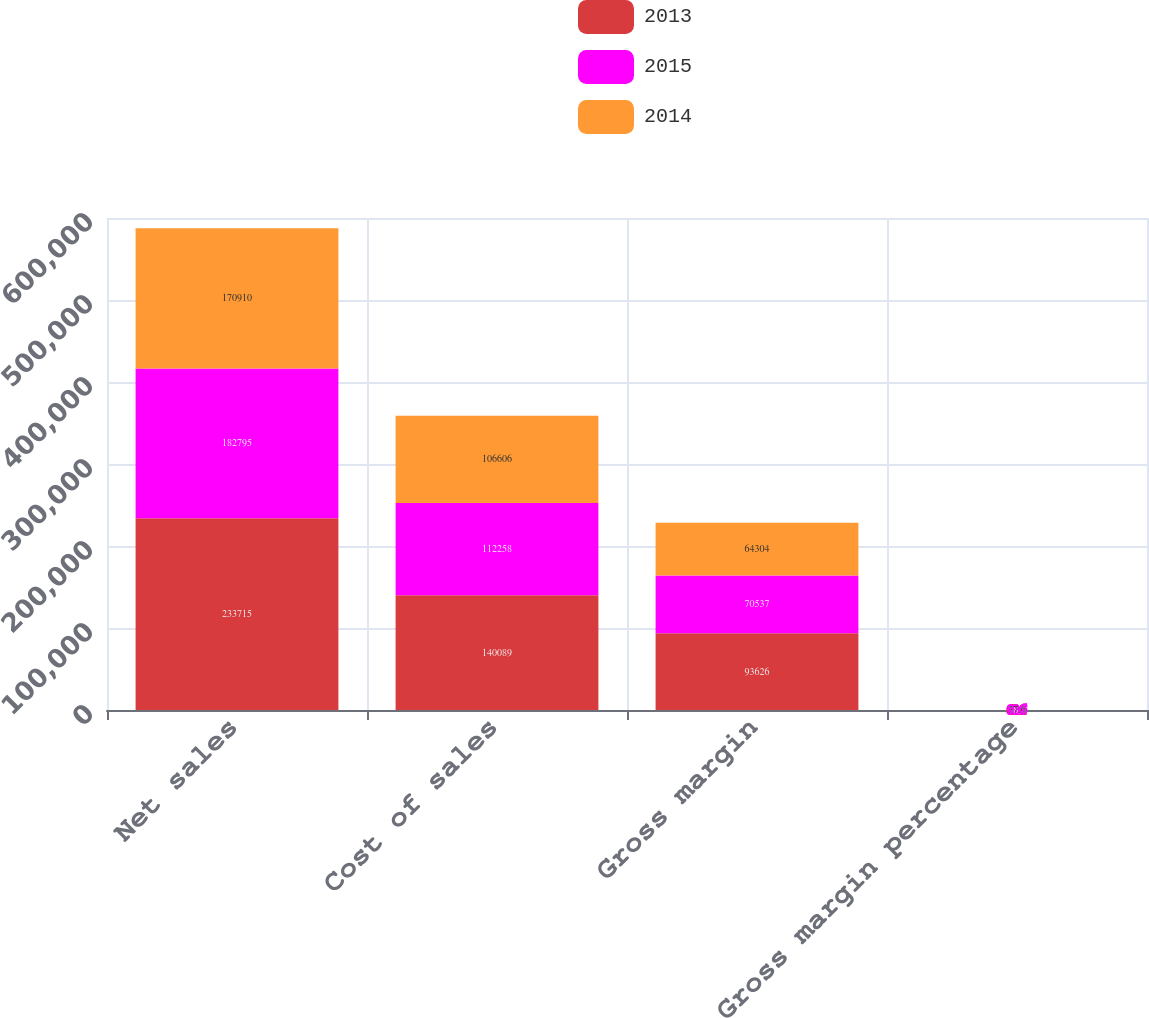Convert chart. <chart><loc_0><loc_0><loc_500><loc_500><stacked_bar_chart><ecel><fcel>Net sales<fcel>Cost of sales<fcel>Gross margin<fcel>Gross margin percentage<nl><fcel>2013<fcel>233715<fcel>140089<fcel>93626<fcel>40.1<nl><fcel>2015<fcel>182795<fcel>112258<fcel>70537<fcel>38.6<nl><fcel>2014<fcel>170910<fcel>106606<fcel>64304<fcel>37.6<nl></chart> 